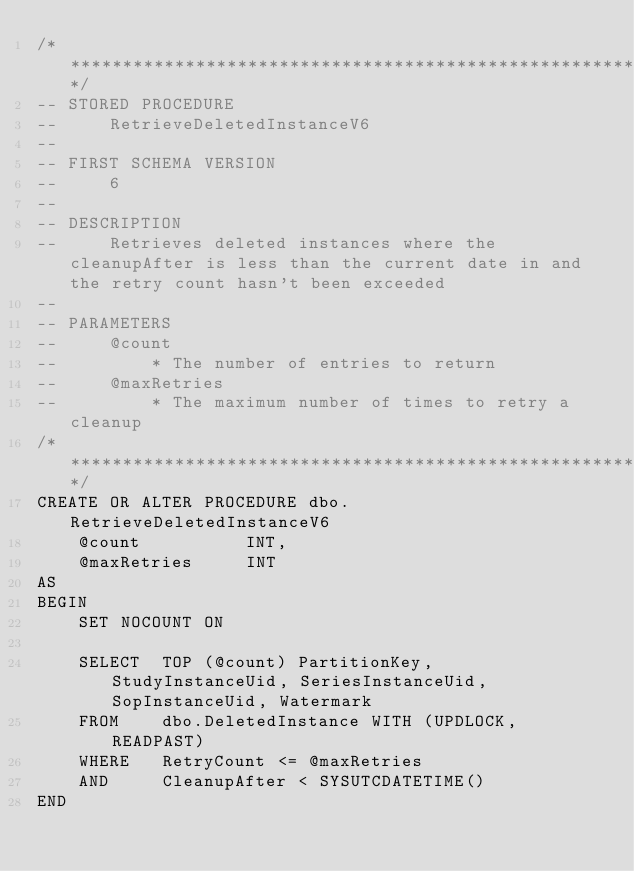Convert code to text. <code><loc_0><loc_0><loc_500><loc_500><_SQL_>/***************************************************************************************/
-- STORED PROCEDURE
--     RetrieveDeletedInstanceV6
--
-- FIRST SCHEMA VERSION
--     6
--
-- DESCRIPTION
--     Retrieves deleted instances where the cleanupAfter is less than the current date in and the retry count hasn't been exceeded
--
-- PARAMETERS
--     @count
--         * The number of entries to return
--     @maxRetries
--         * The maximum number of times to retry a cleanup
/***************************************************************************************/
CREATE OR ALTER PROCEDURE dbo.RetrieveDeletedInstanceV6
    @count          INT,
    @maxRetries     INT
AS
BEGIN
    SET NOCOUNT ON

    SELECT  TOP (@count) PartitionKey, StudyInstanceUid, SeriesInstanceUid, SopInstanceUid, Watermark
    FROM    dbo.DeletedInstance WITH (UPDLOCK, READPAST)
    WHERE   RetryCount <= @maxRetries
    AND     CleanupAfter < SYSUTCDATETIME()
END
</code> 